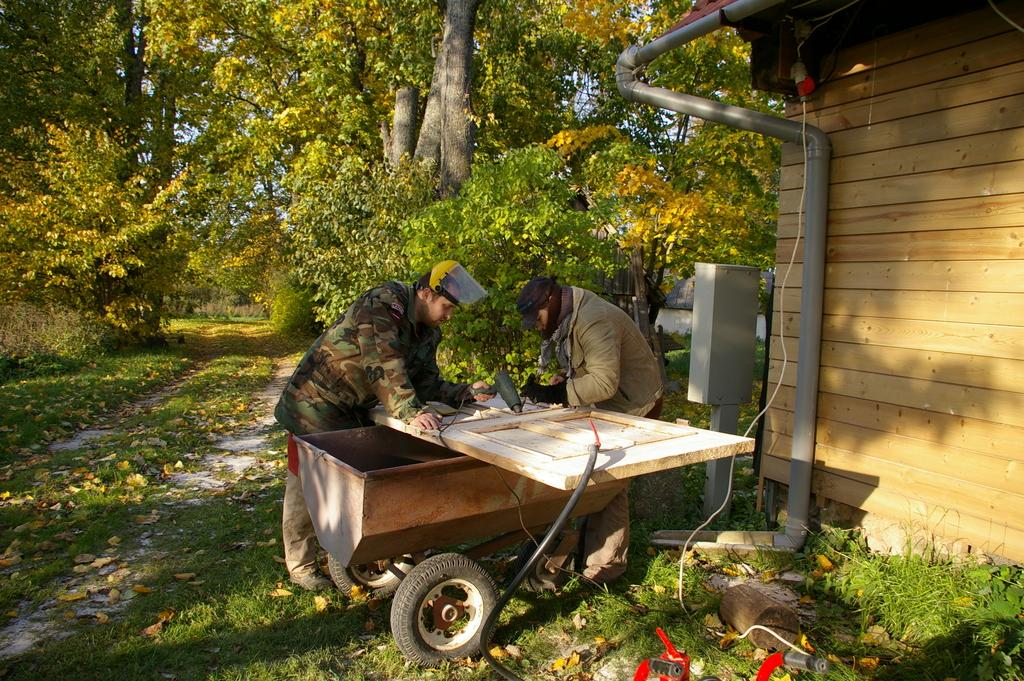How many people are in the image? There are people in the image, but the exact number is not specified. What type of terrain is visible in the image? There is grass in the image, which suggests a natural setting. What type of object can be used to transport items in the image? There is a cart in the image, which can be used for transportation. What material is used to construct the wooden object in the image? The wooden object in the image is made of wood. What type of object can be used for carrying water or other fluids in the image? There is a pipe in the image, which can be used for carrying fluids. What type of structure is made of wooden planks in the image? There is a wooden wall in the image, which is a type of structure. What type of flat, rigid object is present in the image? There is a board in the image, which is a flat, rigid object. What type of vegetation is visible in the image? There are trees in the image, which are a type of vegetation. Where is the store located in the image? There is no store present in the image. What type of feather can be seen on the wooden wall in the image? There are no feathers present in the image, and the wooden wall is not associated with any feathers. 